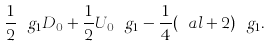Convert formula to latex. <formula><loc_0><loc_0><loc_500><loc_500>\frac { 1 } { 2 } \ g _ { 1 } D _ { 0 } + \frac { 1 } { 2 } U _ { 0 } \ g _ { 1 } - \frac { 1 } { 4 } ( \ a l + 2 ) \ g _ { 1 } .</formula> 